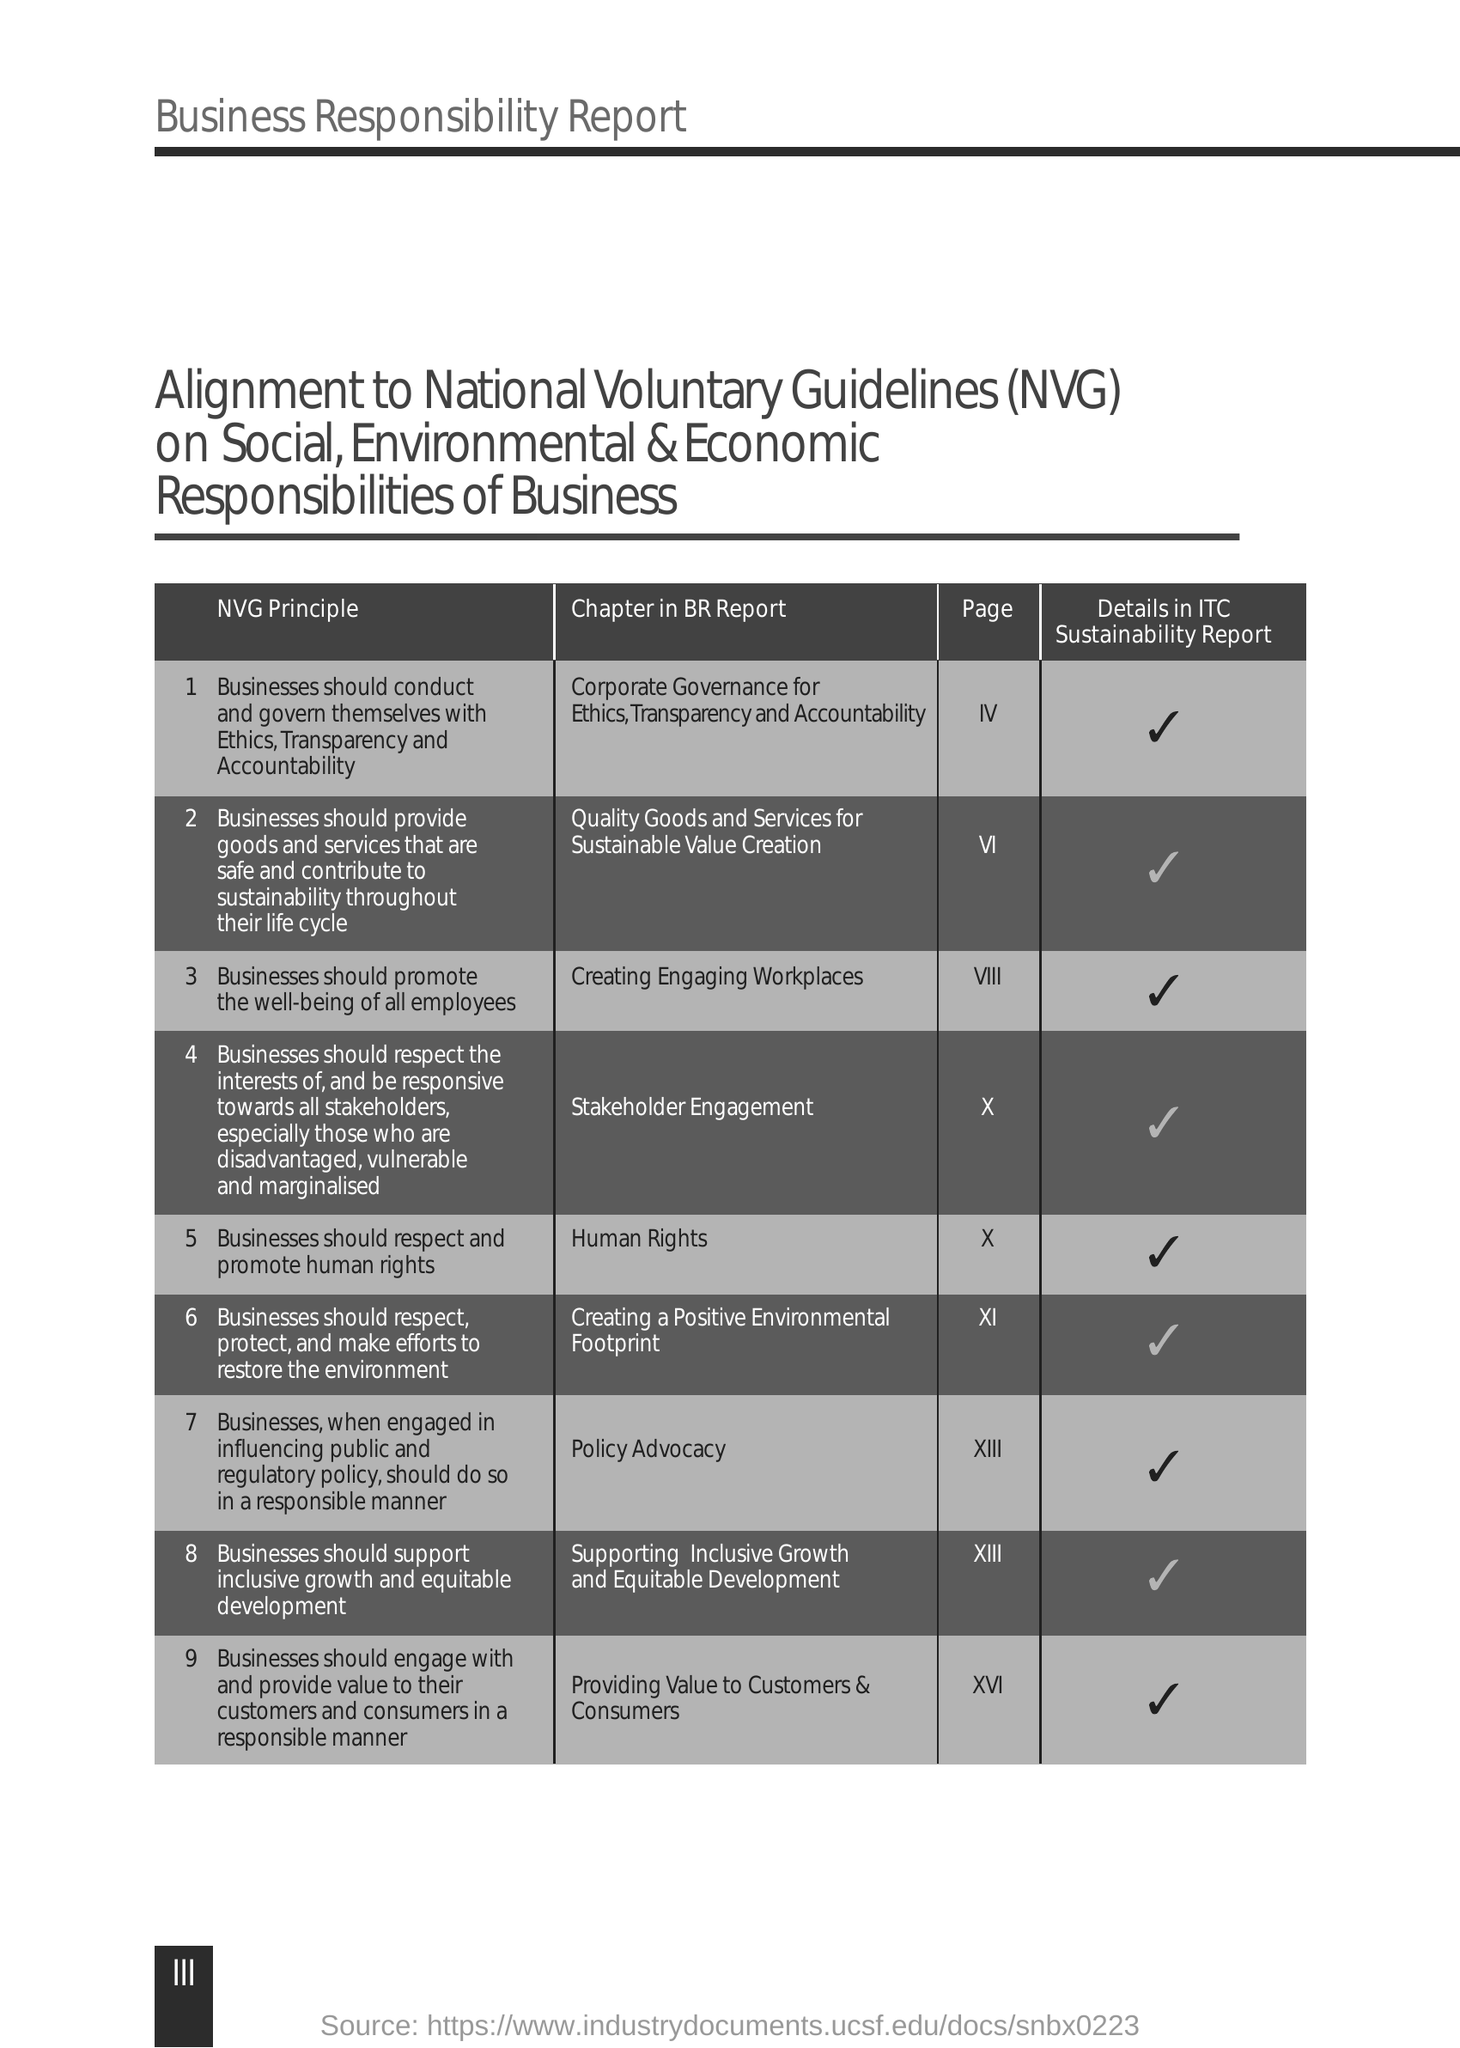What is the Fullform of NVG ?
Your answer should be compact. National Voluntary Guidelines. 